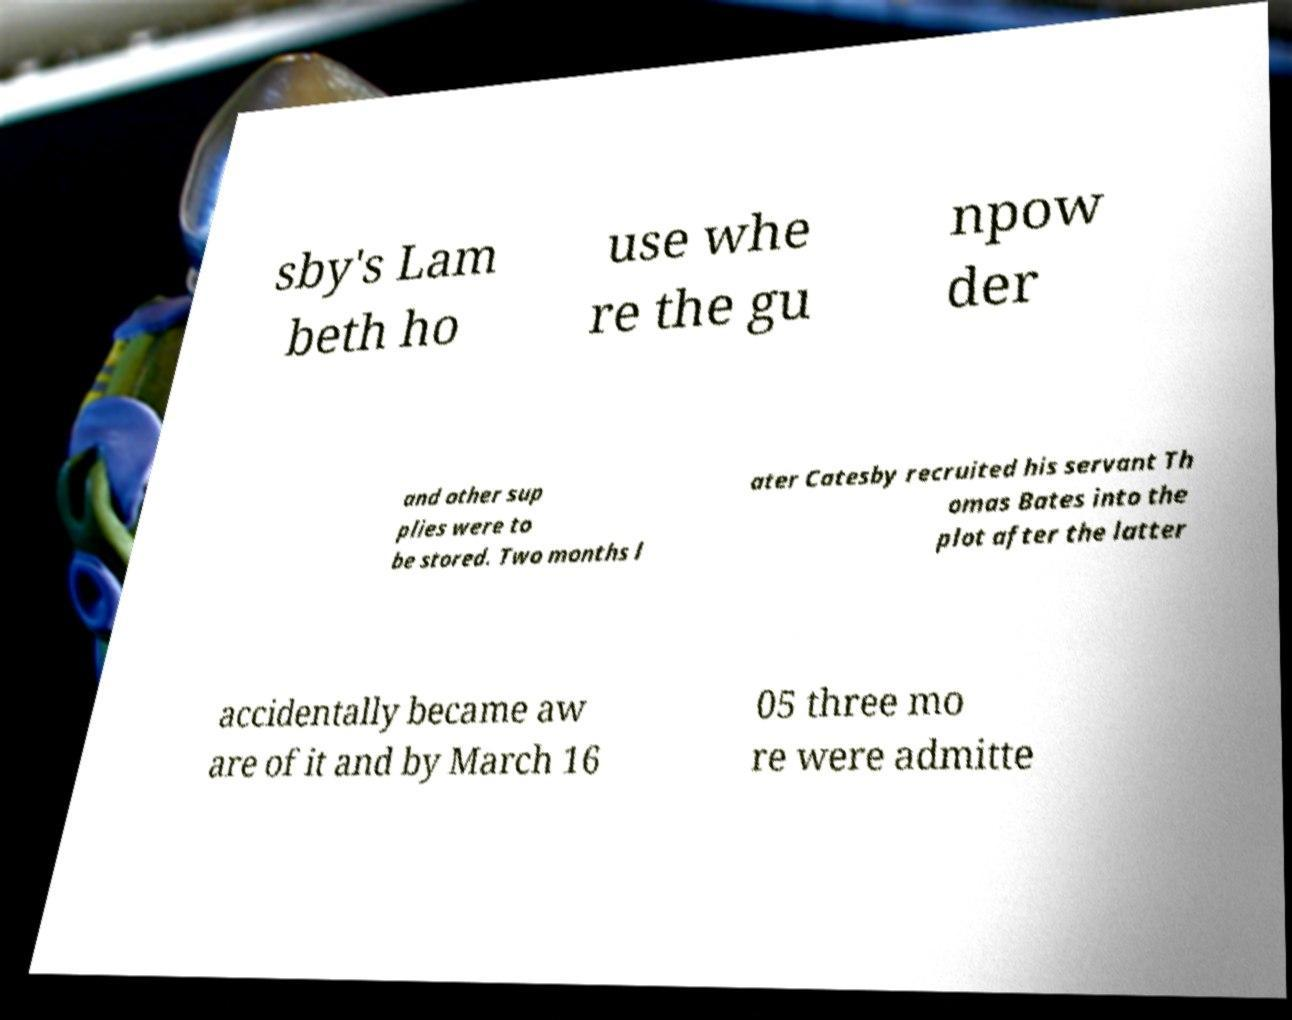Could you assist in decoding the text presented in this image and type it out clearly? sby's Lam beth ho use whe re the gu npow der and other sup plies were to be stored. Two months l ater Catesby recruited his servant Th omas Bates into the plot after the latter accidentally became aw are of it and by March 16 05 three mo re were admitte 